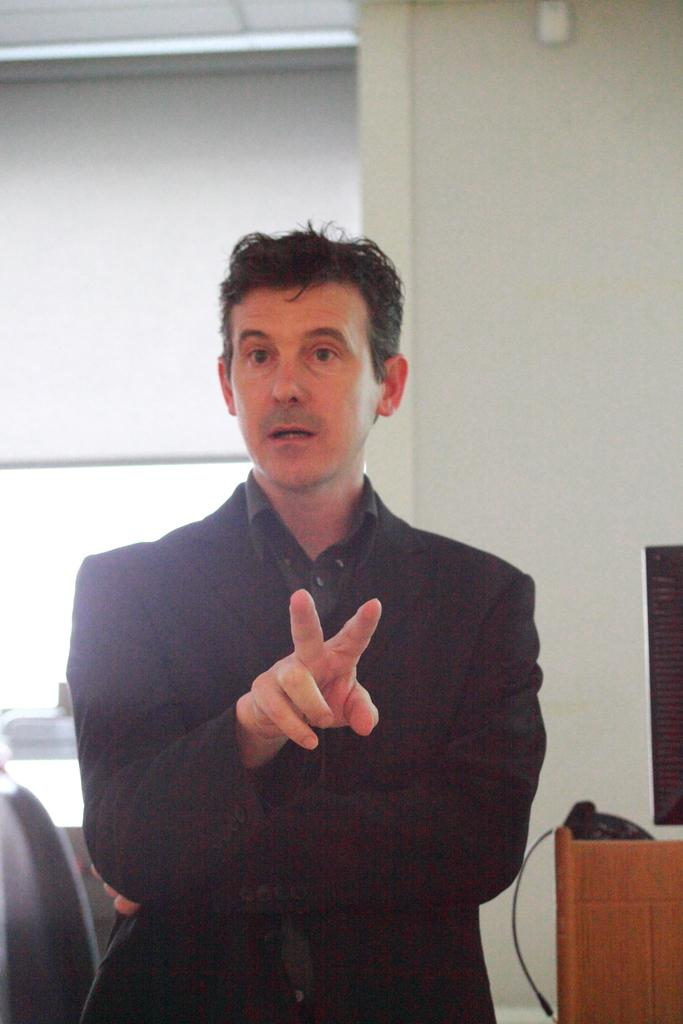What is the main subject of the image? There is a man in the image. What is the man wearing in the image? The man is wearing a blazer. What can be seen in the background of the image? There is a wall and a window in the background of the image. Are there any objects visible in the background of the image? Yes, there are some objects visible in the background of the image. What type of sack is the man carrying in the image? There is no sack visible in the image; the man is not carrying anything. How does the man's temper affect the objects in the background of the image? There is no indication of the man's temper in the image, and therefore it cannot be determined how it might affect the objects in the background. 